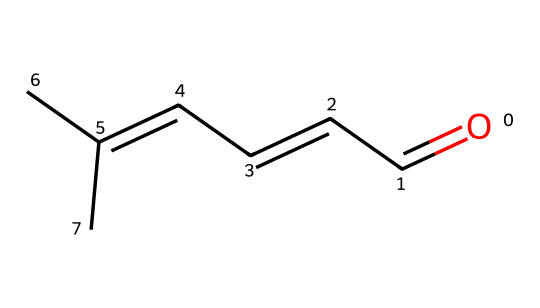What is the functional group present in cinnamaldehyde? The structure of cinnamaldehyde shows a carbonyl group (C=O) attached to a carbon (aldehyde). This defines the compound as an aldehyde.
Answer: aldehyde How many carbon atoms are in the structure of cinnamaldehyde? Counting the carbon atoms in the given SMILES representation, there are a total of 9 carbon atoms present (C=C and the linear chain).
Answer: 9 What type of isomerism is exhibited by cinnamaldehyde? Cinnamaldehyde can exhibit geometric isomerism due to the presence of a double bond in the alkene portion of its structure, where cis and trans forms can exist.
Answer: geometric What is the molecular formula of cinnamaldehyde? To derive the molecular formula from the SMILES representation, we identify that there are 9 carbon atoms, 8 hydrogen atoms, and 1 oxygen atom, giving us C9H8O.
Answer: C9H8O How many double bonds are present in cinnamaldehyde? The structure shows one double bond between carbon atoms in the alkene chain after the carbonyl group, indicating the presence of one double bond.
Answer: 1 What does the 'O=' in the SMILES representation indicate? The 'O=' indicates a carbonyl functional group, which is characteristic of aldehydes, positioning an oxygen atom double-bonded to a carbon atom indicating it's at the end of the carbon chain.
Answer: carbonyl What is the common use of cinnamaldehyde in food products? Cinnamaldehyde is primarily used for its flavoring properties to impart the characteristic taste of cinnamon in various food and beverage products.
Answer: flavoring 